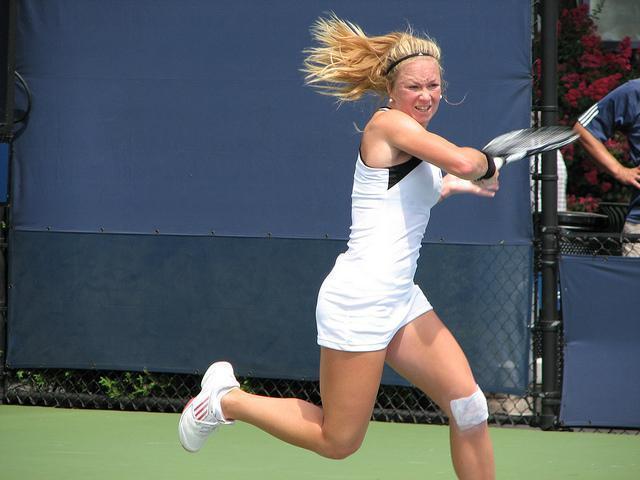What happened to this players left knee?
Choose the correct response and explain in the format: 'Answer: answer
Rationale: rationale.'
Options: Break, sunburn, nothing, cut. Answer: cut.
Rationale: The bandage is small and the athlete is still able to play. 